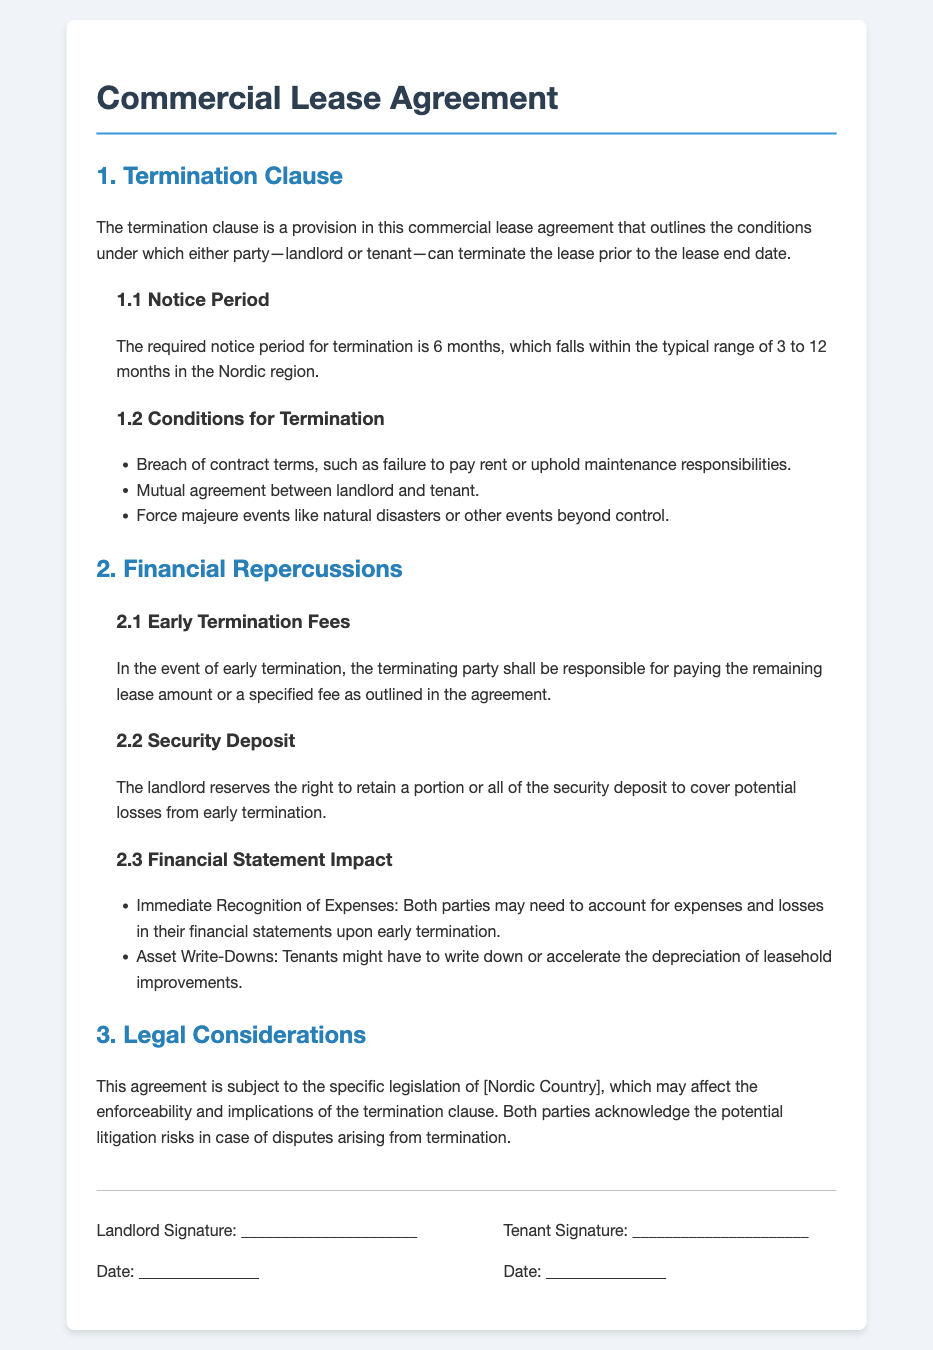what is the notice period for termination? The required notice period for termination is specified in section 1.1 of the document, which states it is 6 months.
Answer: 6 months what are the conditions for termination? There are three specified conditions for termination in section 1.2 of the document, including breach of contract.
Answer: Breach of contract, mutual agreement, force majeure what happens in case of early termination? The financial repercussions of early termination are outlined in section 2.1, which states that the terminating party is responsible for paying either the remaining lease amount or a specified fee.
Answer: Remaining lease amount or specified fee what rights does the landlord have regarding the security deposit? In section 2.2, the document indicates the landlord's right to retain a portion or all of the security deposit to cover losses.
Answer: Retain a portion or all what financial impact may occur for tenants upon early termination? The financial repercussions for tenants are discussed in section 2.3, detailing the need to account for expenses and losses.
Answer: Immediate recognition of expenses what legislation governs this agreement? The document states that the agreement is subject to legislation of a specified Nordic country, which affects enforceability in section 3.
Answer: [Nordic Country] how is the termination clause titled in the document? The title of the termination clause is clearly indicated as the first main section of the agreement.
Answer: 1. Termination Clause how long is the typical notice period range in the Nordic region? The document mentions that the typical range for notice periods in the Nordic region is stated in section 1.1.
Answer: 3 to 12 months 